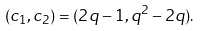Convert formula to latex. <formula><loc_0><loc_0><loc_500><loc_500>( c _ { 1 } , c _ { 2 } ) = ( 2 q - 1 , q ^ { 2 } - 2 q ) .</formula> 